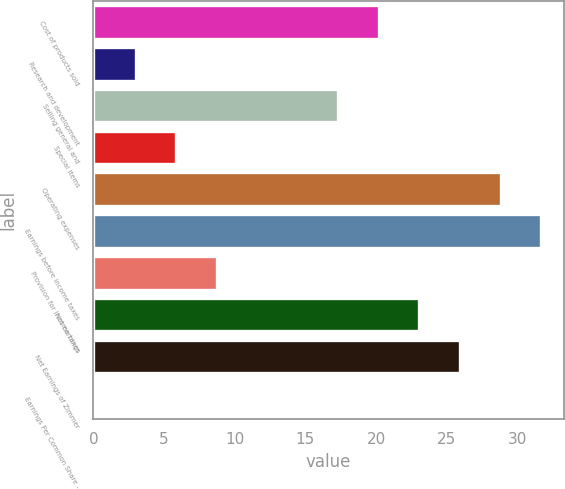Convert chart. <chart><loc_0><loc_0><loc_500><loc_500><bar_chart><fcel>Cost of products sold<fcel>Research and development<fcel>Selling general and<fcel>Special items<fcel>Operating expenses<fcel>Earnings before income taxes<fcel>Provision for income taxes<fcel>Net earnings<fcel>Net Earnings of Zimmer<fcel>Earnings Per Common Share -<nl><fcel>20.2<fcel>2.98<fcel>17.33<fcel>5.85<fcel>28.81<fcel>31.68<fcel>8.72<fcel>23.07<fcel>25.94<fcel>0.11<nl></chart> 